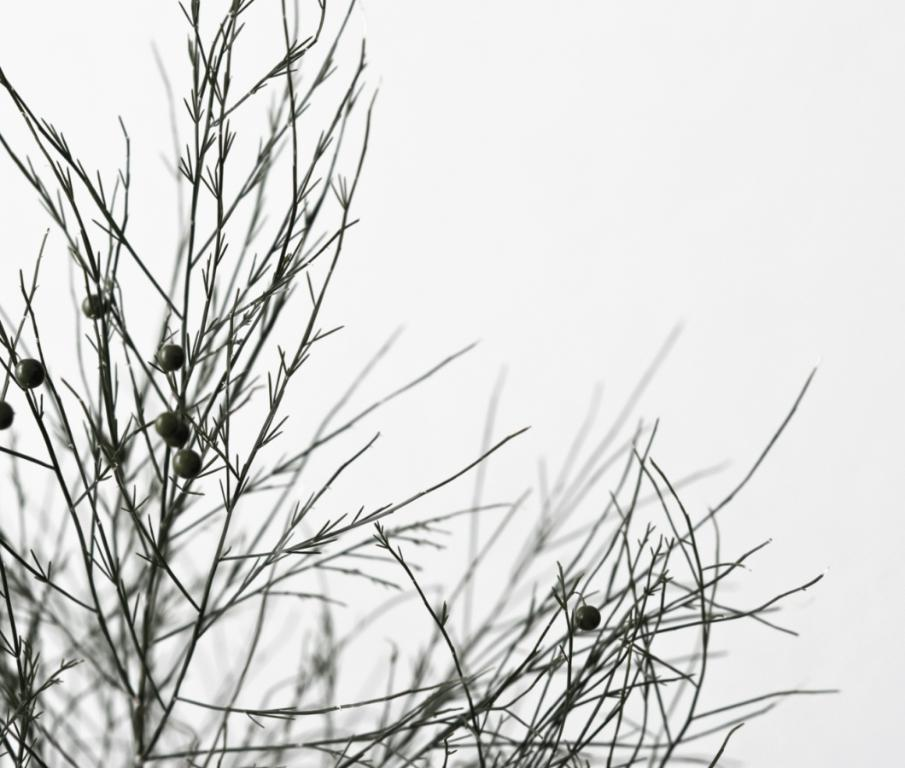What type of vegetation is present in the image? There are plants in the image. Can you describe the appearance of the plants? The plants resemble grass. How many fingers can be seen holding the pen in the image? There is no pen or fingers present in the image; it only features plants that resemble grass. 